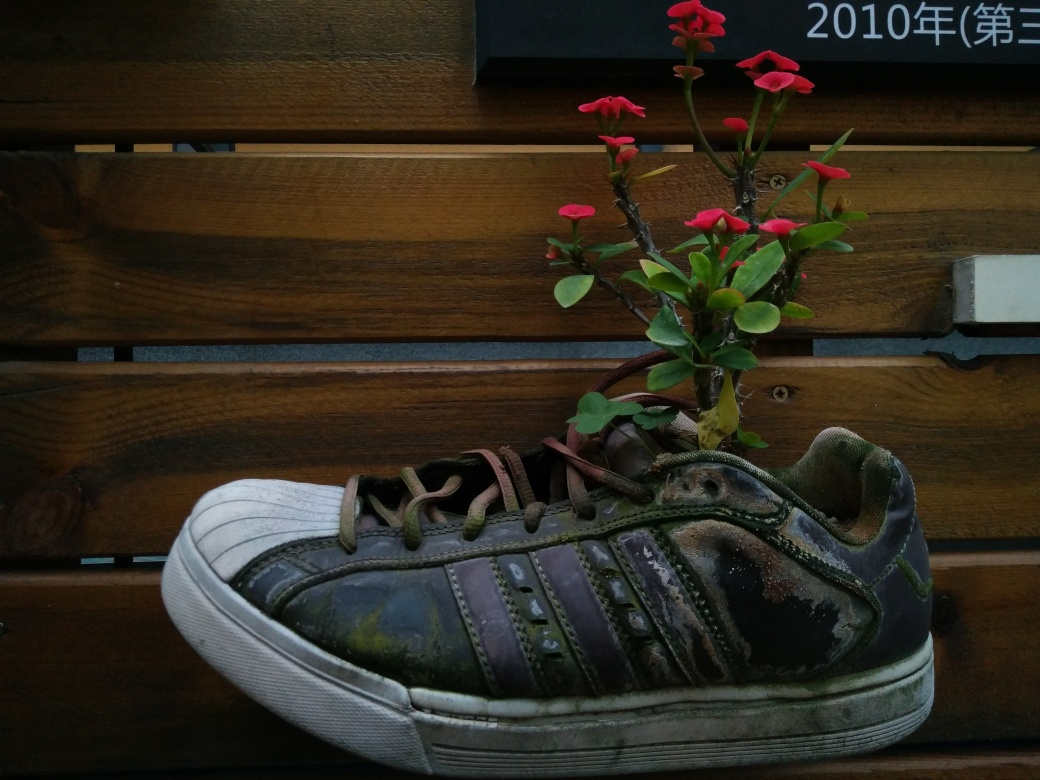Could there be any symbolic meaning behind the placement of the flower in the shoe? Symbolically, the flower growing out of the shoe could represent resilience and rejuvenation, suggesting that new life and beauty can arise in places where it's least expected. It might also imply a contrast between the natural and the man-made, reflecting on the relationship between humanity and nature. 